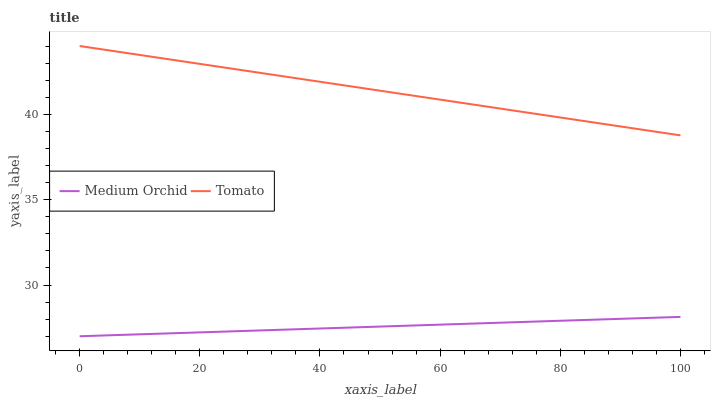Does Medium Orchid have the maximum area under the curve?
Answer yes or no. No. Is Medium Orchid the roughest?
Answer yes or no. No. Does Medium Orchid have the highest value?
Answer yes or no. No. Is Medium Orchid less than Tomato?
Answer yes or no. Yes. Is Tomato greater than Medium Orchid?
Answer yes or no. Yes. Does Medium Orchid intersect Tomato?
Answer yes or no. No. 